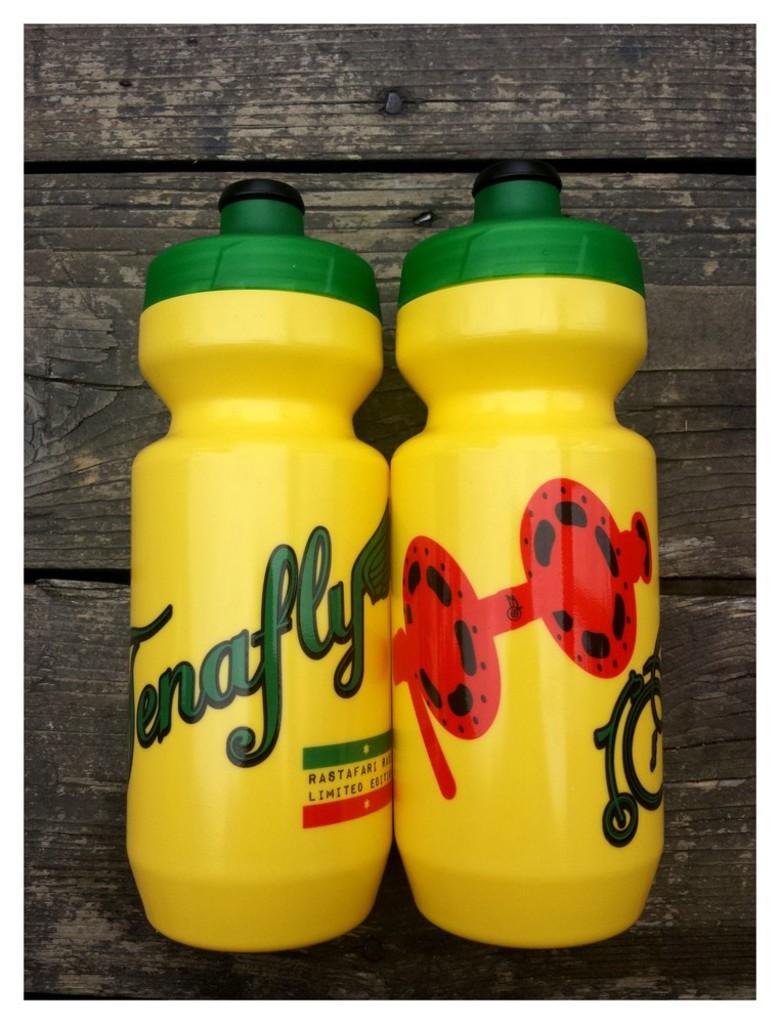What does the green letters say?
Offer a very short reply. Tenafly. 